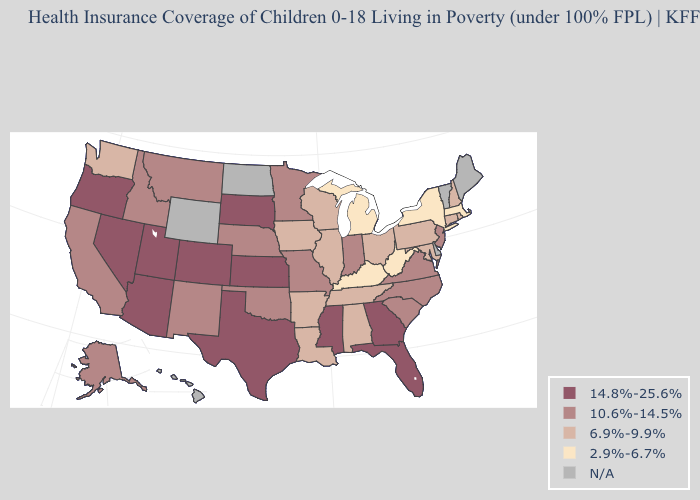Is the legend a continuous bar?
Short answer required. No. Name the states that have a value in the range 10.6%-14.5%?
Keep it brief. Alaska, California, Idaho, Indiana, Minnesota, Missouri, Montana, Nebraska, New Jersey, New Mexico, North Carolina, Oklahoma, South Carolina, Virginia. What is the value of Connecticut?
Concise answer only. 6.9%-9.9%. What is the highest value in states that border New Mexico?
Be succinct. 14.8%-25.6%. Name the states that have a value in the range 14.8%-25.6%?
Quick response, please. Arizona, Colorado, Florida, Georgia, Kansas, Mississippi, Nevada, Oregon, South Dakota, Texas, Utah. Name the states that have a value in the range N/A?
Be succinct. Delaware, Hawaii, Maine, North Dakota, Vermont, Wyoming. What is the value of Florida?
Concise answer only. 14.8%-25.6%. What is the value of Mississippi?
Answer briefly. 14.8%-25.6%. What is the value of Utah?
Be succinct. 14.8%-25.6%. Which states have the highest value in the USA?
Be succinct. Arizona, Colorado, Florida, Georgia, Kansas, Mississippi, Nevada, Oregon, South Dakota, Texas, Utah. Does Florida have the highest value in the USA?
Write a very short answer. Yes. Name the states that have a value in the range N/A?
Keep it brief. Delaware, Hawaii, Maine, North Dakota, Vermont, Wyoming. Name the states that have a value in the range 2.9%-6.7%?
Concise answer only. Kentucky, Massachusetts, Michigan, New York, West Virginia. What is the value of South Carolina?
Be succinct. 10.6%-14.5%. Name the states that have a value in the range 14.8%-25.6%?
Quick response, please. Arizona, Colorado, Florida, Georgia, Kansas, Mississippi, Nevada, Oregon, South Dakota, Texas, Utah. 